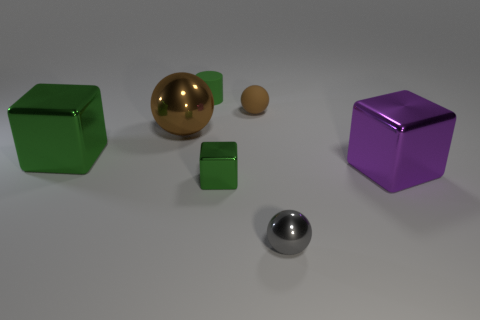Add 3 blue matte blocks. How many objects exist? 10 Subtract all blocks. How many objects are left? 4 Add 4 big metallic objects. How many big metallic objects are left? 7 Add 7 small spheres. How many small spheres exist? 9 Subtract 0 gray cubes. How many objects are left? 7 Subtract all brown balls. Subtract all brown spheres. How many objects are left? 3 